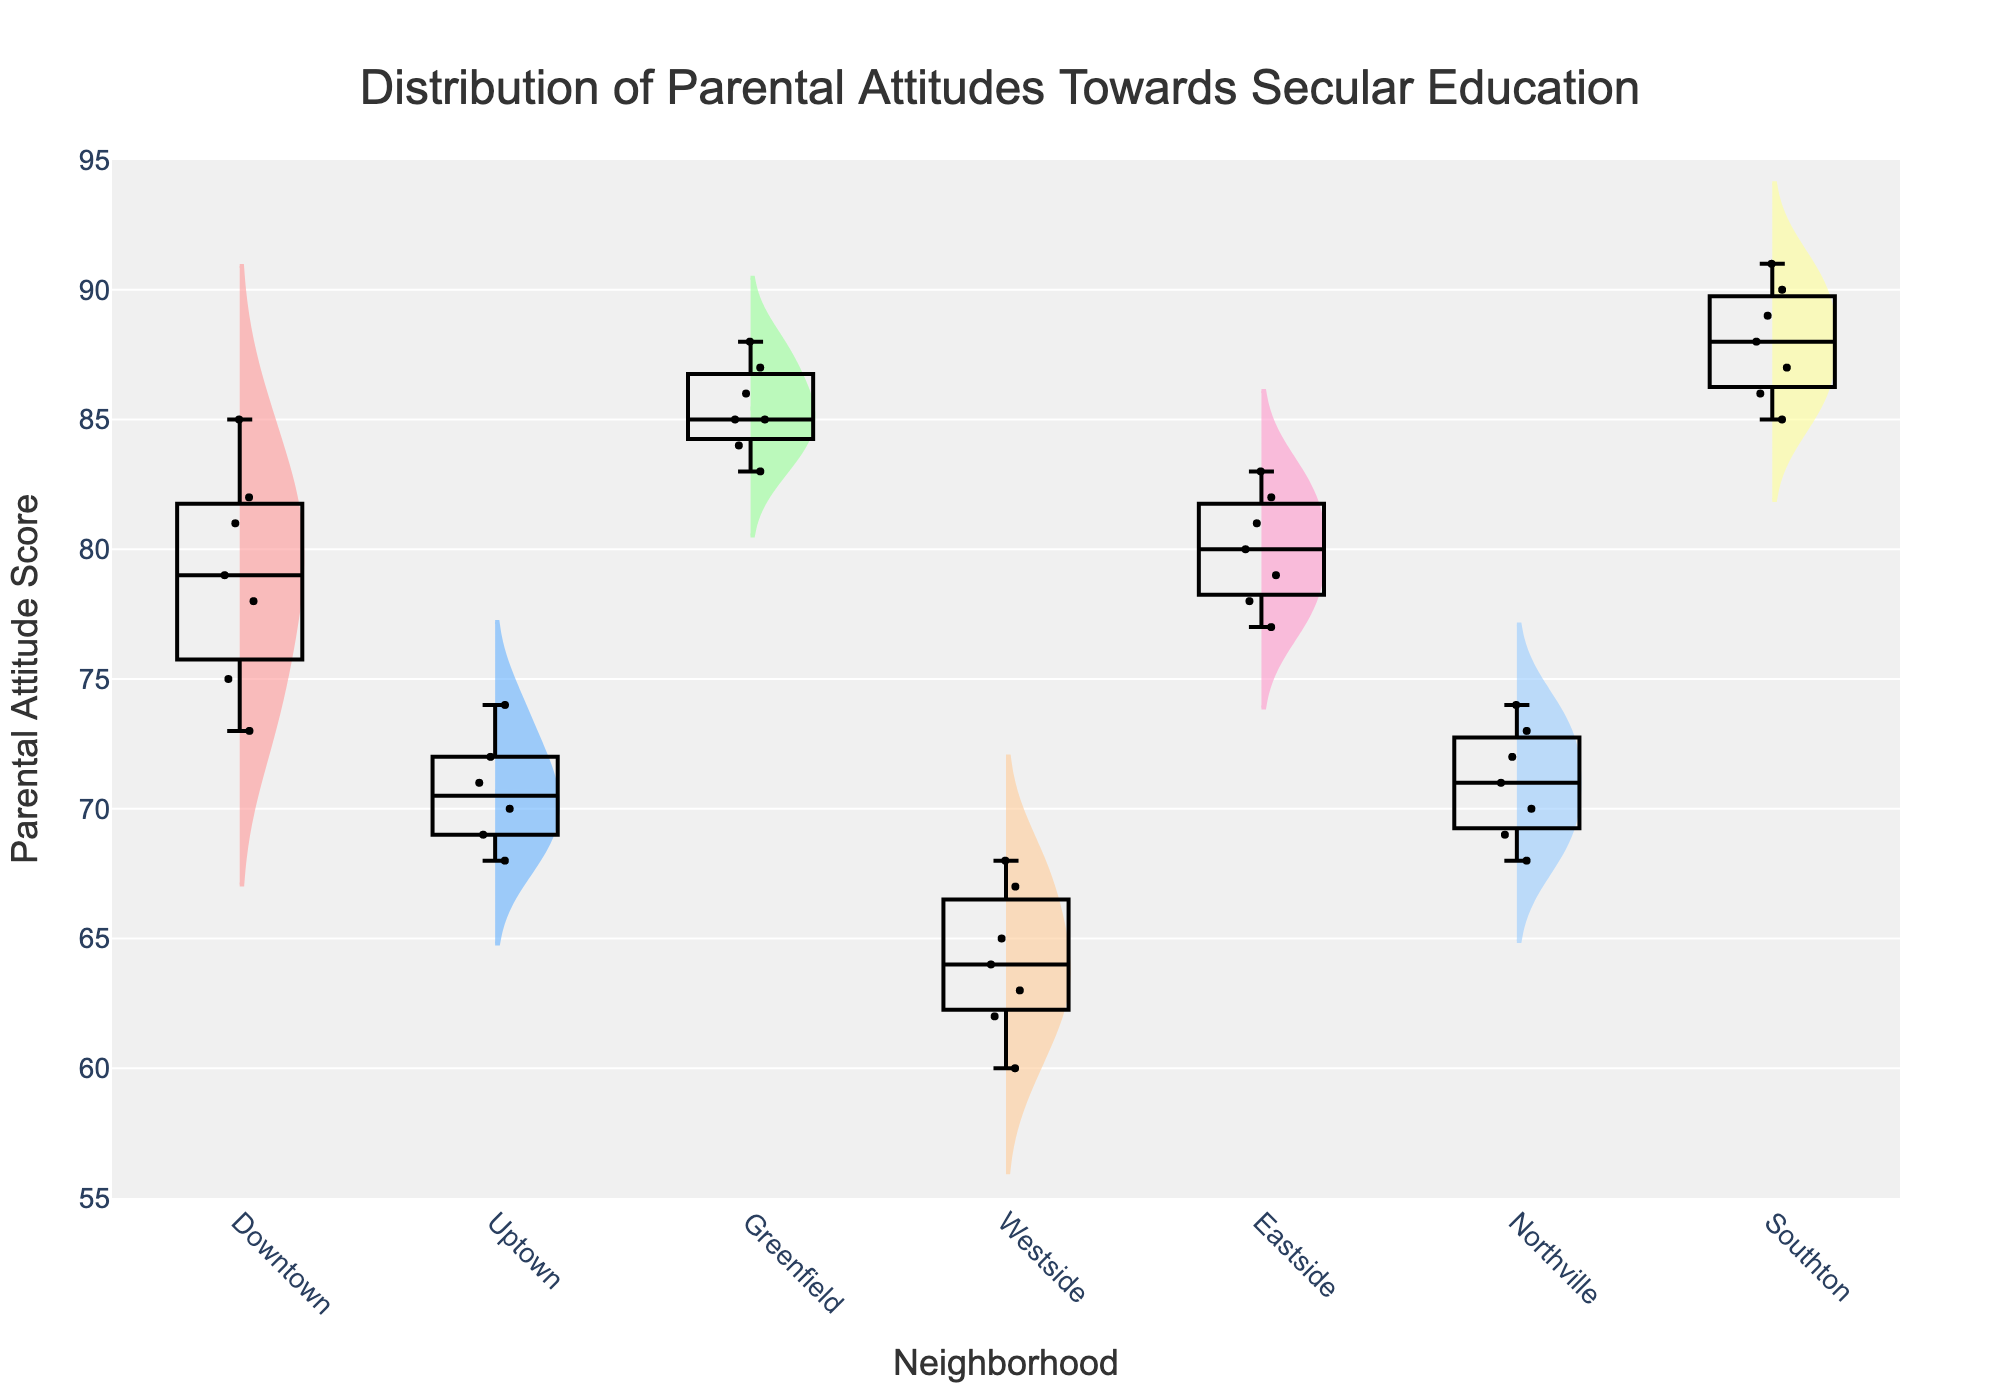what is the title of the figure? The title is displayed at the top of the figure. It summarizes the content of the chart, indicating what the viewer is expected to learn or observe. The title reads "Distribution of Parental Attitudes Towards Secular Education."
Answer: Distribution of Parental Attitudes Towards Secular Education Which neighborhood has the highest median parental attitude score? To answer this, we look for the line within each box plot that represents the median value. The highest median line appears in Southton.
Answer: Southton What is the interquartile range of parental attitude scores in Downtown? The interquartile range (IQR) is found by subtracting the lower quartile value (25th percentile) from the upper quartile value (75th percentile) in the box plot. For Downtown, these values approximately correspond to 73 and 82 respectively, so the IQR is 82 - 73 = 9.
Answer: 9 Which neighborhoods have the most overlap in their parental attitude score distributions? To compare overlaps, we observe the widths and positions of the violin plots. Uptown and Northville have similarly positioned and overlapping distributions around the score range of 68 to 74.
Answer: Uptown and Northville How many data points are there for the Westside neighborhood? Each dot in the box plot represents an individual data point. Counting the dots within the Westside box plot provides the number of data points, which is 7.
Answer: 7 How does the range of parental attitude scores in Eastside compare to that in Westside? By comparing the whiskers' length in the box plots to observe the spread of the data, Eastside ranges approximately from 77 to 83, whereas Westside ranges from 60 to 68, indicating Eastside has a smaller range.
Answer: Eastside has a smaller range Which neighborhood shows the least variation in parental attitude scores? Variation can be evaluated by the width of the violin plot and the length of the box plot whiskers. The smallest width and whisker length appear in Eastside, indicating the least variation.
Answer: Eastside What is the mean parental attitude score in Southton? Each violin plot includes a central dotted line representing the mean. For Southton, this mean line is approximately at 88.
Answer: 88 Which two neighborhoods display the greatest difference in their median parental attitude scores? We identify the median lines in each box plot for all neighborhoods and find the difference. The greatest difference is between Southton (highest) and Westside (lowest).
Answer: Southton and Westside Are there any outliers in the parental attitude scores? If so, which neighborhood(s)? Outliers are individual dots that fall outside the whiskers of the box plots. No dots fall outside the whiskers, so there are no outliers in any neighborhood.
Answer: No 